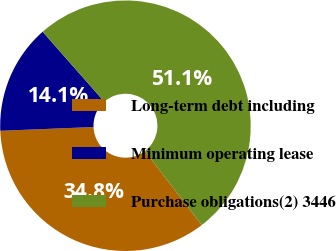Convert chart to OTSL. <chart><loc_0><loc_0><loc_500><loc_500><pie_chart><fcel>Long-term debt including<fcel>Minimum operating lease<fcel>Purchase obligations(2) 3446<nl><fcel>34.78%<fcel>14.15%<fcel>51.07%<nl></chart> 